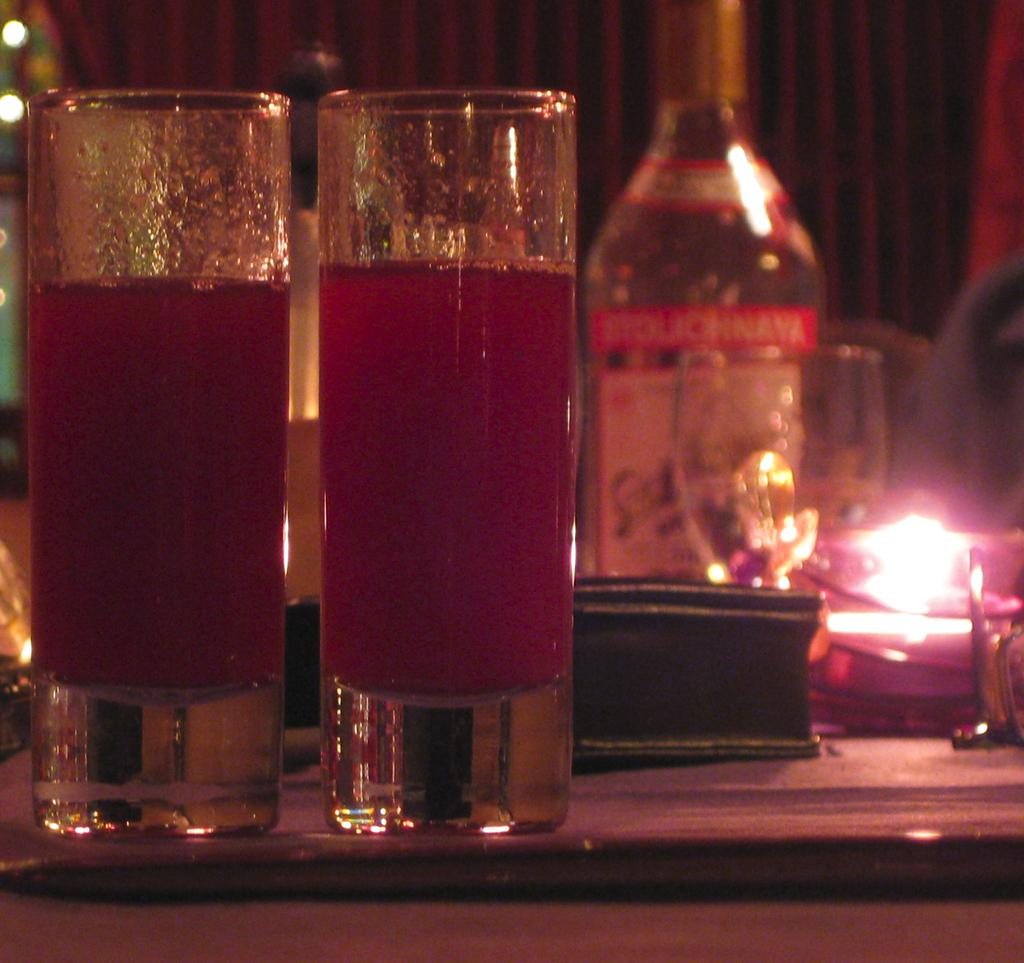How many glasses are visible in the image? There are two glasses in the image. What is inside the glasses? The glasses contain juice. What is located at the right side of the image? There is a bottle at the right side of the image. Where are the glasses and bottle placed? The glasses and bottle are placed on a table. What type of scarf is draped over the glasses in the image? There is no scarf present in the image; it only features two glasses containing juice, a bottle, and a table. 